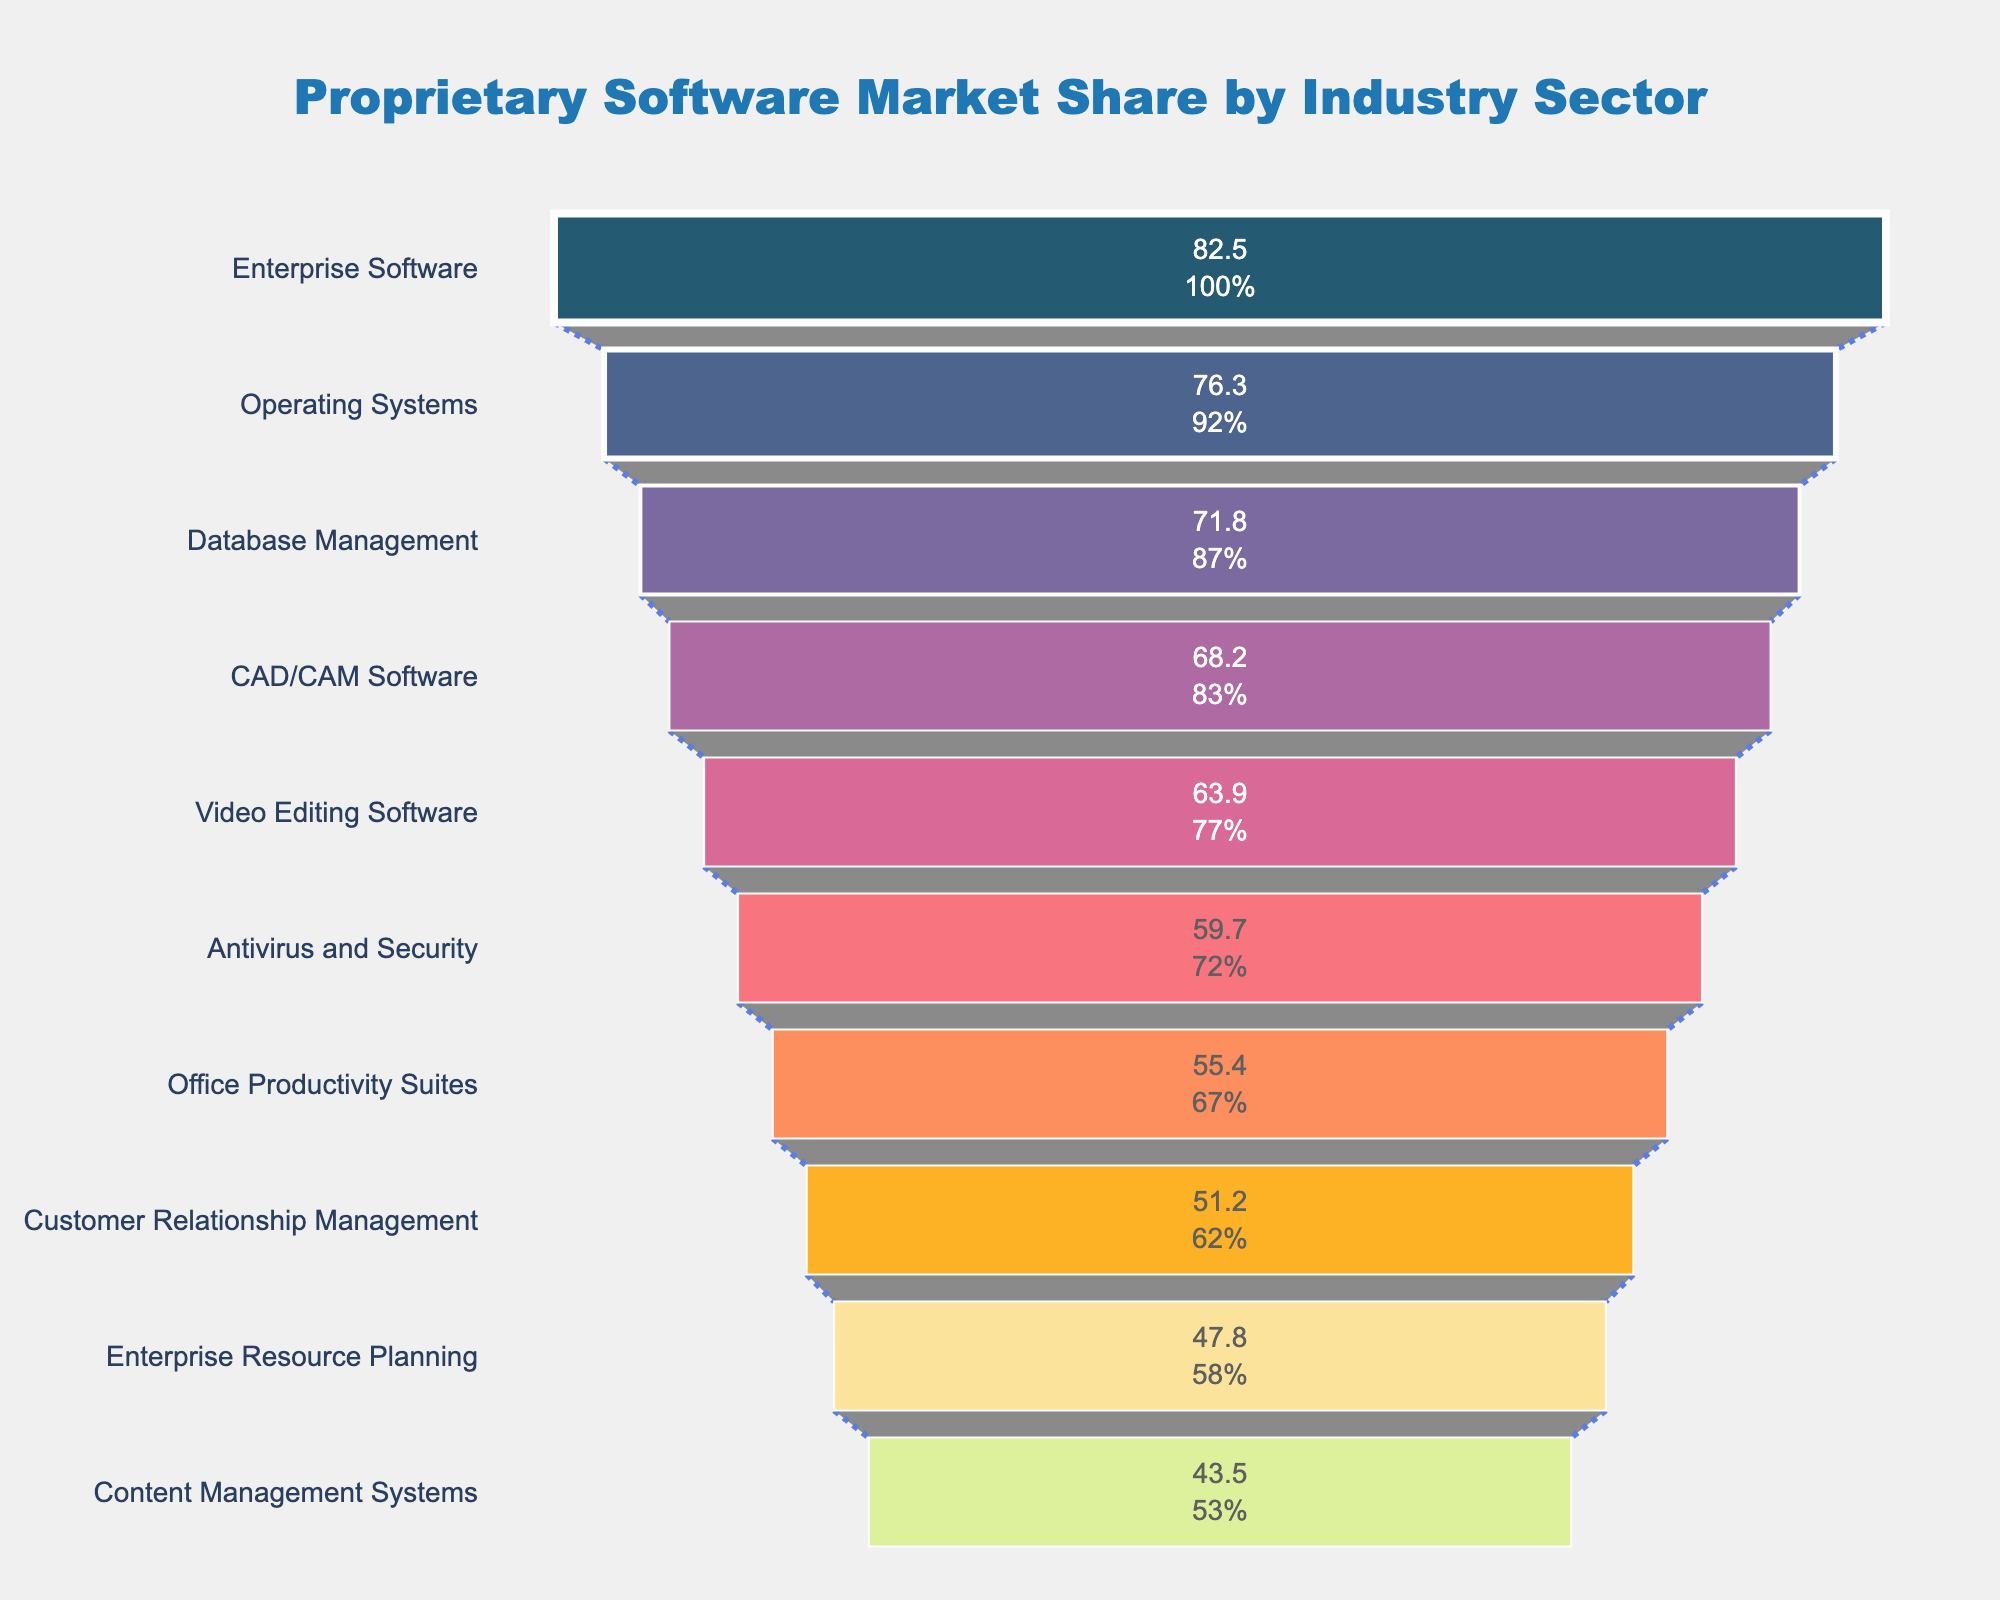Which industry sector has the highest proprietary software market share? The funnel chart shows that the industry sector at the top is "Enterprise Software" with the highest market share.
Answer: Enterprise Software Which industry sector is positioned right below 'Operating Systems' in terms of proprietary software market share? By observing the order of sectors on the funnel, 'Database Management' is positioned right below 'Operating Systems'.
Answer: Database Management How much more is the market share of 'Enterprise Software' compared to 'Video Editing Software'? Subtract the market share of 'Video Editing Software' (63.9) from 'Enterprise Software' (82.5). The difference is 82.5 - 63.9 = 18.6.
Answer: 18.6 What is the combined market share of 'Customer Relationship Management' and 'Enterprise Resource Planning'? Sum the market shares of 'Customer Relationship Management' (51.2) and 'Enterprise Resource Planning' (47.8). The total is 51.2 + 47.8 = 99.
Answer: 99 Which industry sector is ranked fifth in proprietary software market share? The fifth sector in descending order of the market share on the funnel is 'Video Editing Software'.
Answer: Video Editing Software Is 'Office Productivity Suites' market share greater than or less than 'Antivirus and Security'? By looking at their positions, 'Office Productivity Suites' (55.4) has less market share than 'Antivirus and Security' (59.7).
Answer: Less than What proportion of the total initial market share does the top sector (Enterprise Software) represent? First, calculate the total market share by summing all sectors. Sum = 620.3. The proportion for 'Enterprise Software' is (82.5 / 620.3) * 100.
Answer: Approximately 13.3% Which sector has the smallest market share in proprietary software? The final and lowest sector in the funnel is 'Content Management Systems'.
Answer: Content Management Systems What's the average proprietary software market share of the top three industry sectors? Sum the shares of the top three sectors: 82.5 (Enterprise Software), 76.3 (Operating Systems), and 71.8 (Database Management), then divide by 3. Average = (82.5 + 76.3 + 71.8) / 3 = 76.87.
Answer: 76.87 Is there a significant drop in market share between any two consecutive industry sectors listed in the funnel? By observing the funnel, the largest drop occurs between 'Enterprise Software' (82.5) and 'Operating Systems' (76.3), which is a drop of 6.2. This is generally the most significant visible drop.
Answer: Yes, 6.2 